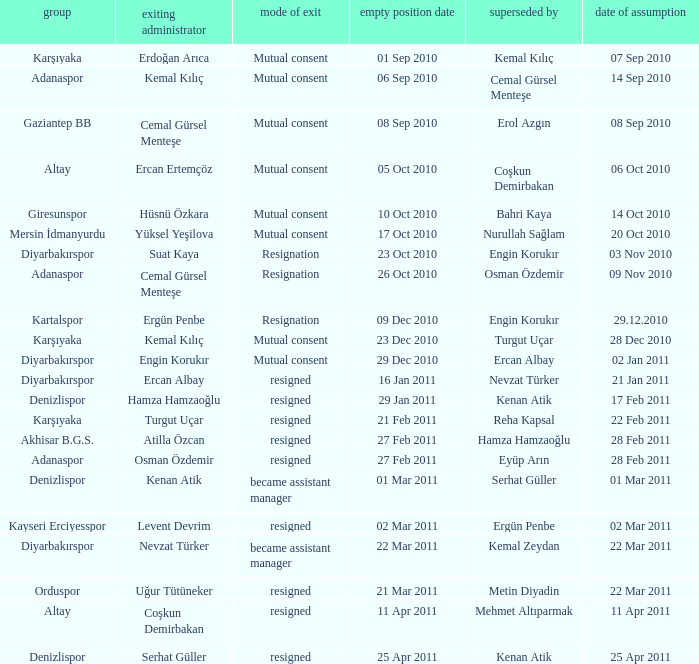Who replaced the outgoing manager Hüsnü Özkara?  Bahri Kaya. 